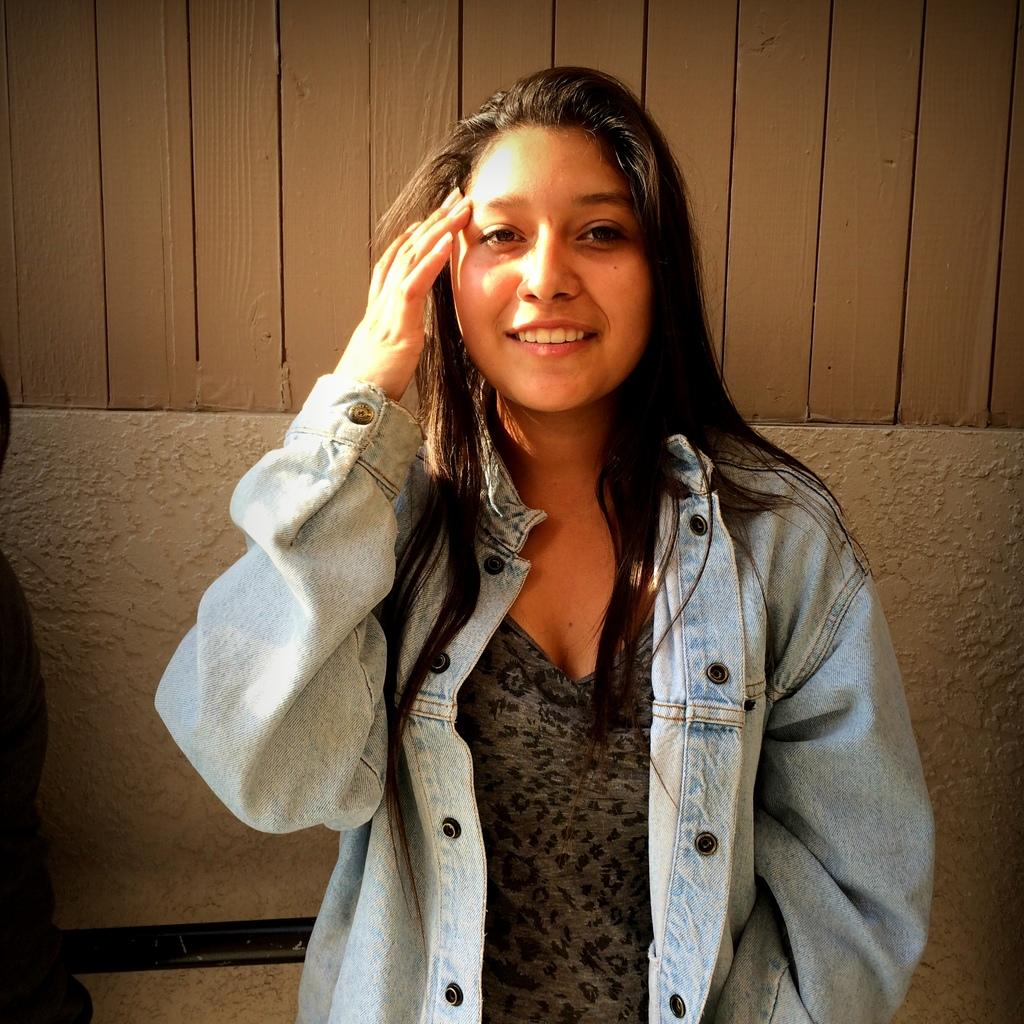What is the woman in the image wearing? The woman is wearing a jeans jacket. What is the woman's facial expression in the image? The woman is smiling. What can be seen in the background of the image? There is a wall in the background of the image. What type of wound can be seen on the woman's arm in the image? There is no wound visible on the woman's arm in the image. What color is the silver cub that the woman is holding in the image? There is no silver cub present in the image. 